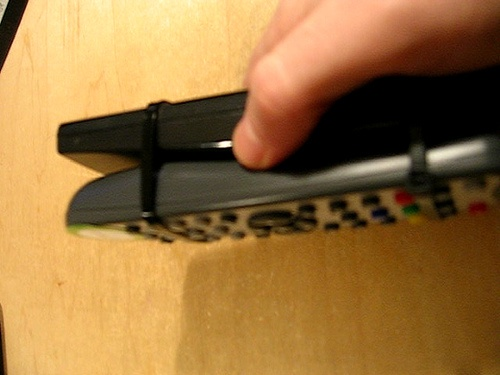Describe the objects in this image and their specific colors. I can see remote in tan, black, darkgreen, maroon, and gray tones and people in tan, maroon, salmon, and brown tones in this image. 